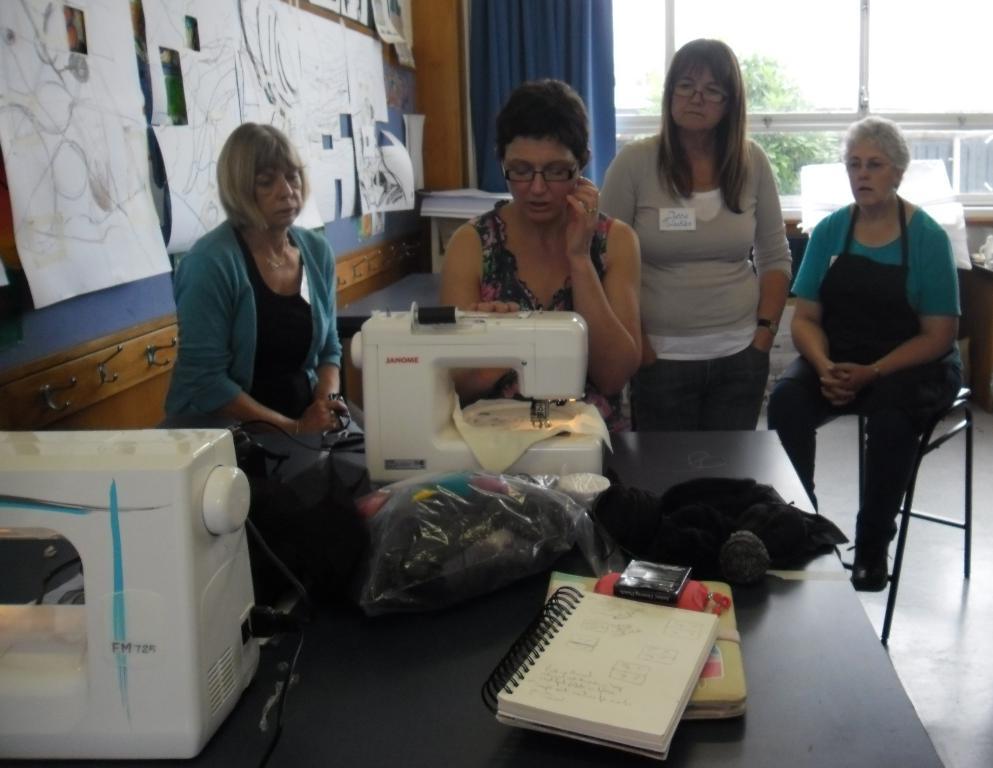Can you describe this image briefly? In this picture I can see few people are sitting, among them one woman is standing and watching, in front there is a table on which some objects are placed, side some papers placed to the board. 